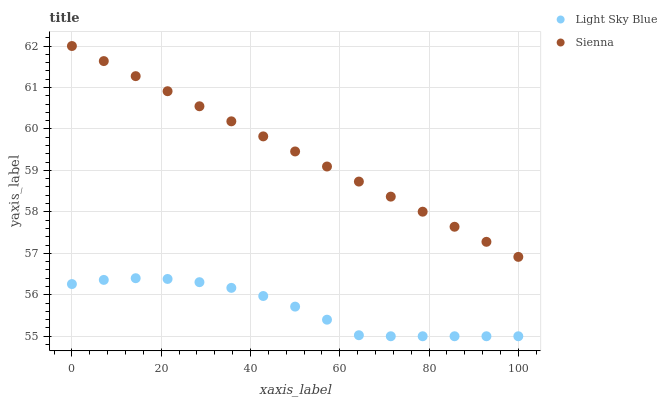Does Light Sky Blue have the minimum area under the curve?
Answer yes or no. Yes. Does Sienna have the maximum area under the curve?
Answer yes or no. Yes. Does Light Sky Blue have the maximum area under the curve?
Answer yes or no. No. Is Sienna the smoothest?
Answer yes or no. Yes. Is Light Sky Blue the roughest?
Answer yes or no. Yes. Is Light Sky Blue the smoothest?
Answer yes or no. No. Does Light Sky Blue have the lowest value?
Answer yes or no. Yes. Does Sienna have the highest value?
Answer yes or no. Yes. Does Light Sky Blue have the highest value?
Answer yes or no. No. Is Light Sky Blue less than Sienna?
Answer yes or no. Yes. Is Sienna greater than Light Sky Blue?
Answer yes or no. Yes. Does Light Sky Blue intersect Sienna?
Answer yes or no. No. 